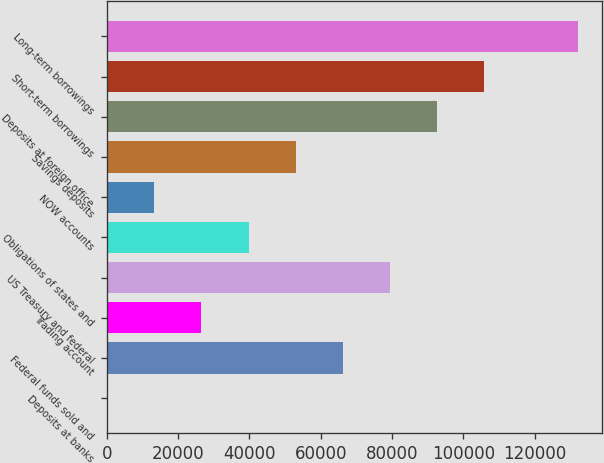<chart> <loc_0><loc_0><loc_500><loc_500><bar_chart><fcel>Deposits at banks<fcel>Federal funds sold and<fcel>Trading account<fcel>US Treasury and federal<fcel>Obligations of states and<fcel>NOW accounts<fcel>Savings deposits<fcel>Deposits at foreign office<fcel>Short-term borrowings<fcel>Long-term borrowings<nl><fcel>112<fcel>66161<fcel>26531.6<fcel>79370.8<fcel>39741.4<fcel>13321.8<fcel>52951.2<fcel>92580.6<fcel>105790<fcel>132210<nl></chart> 